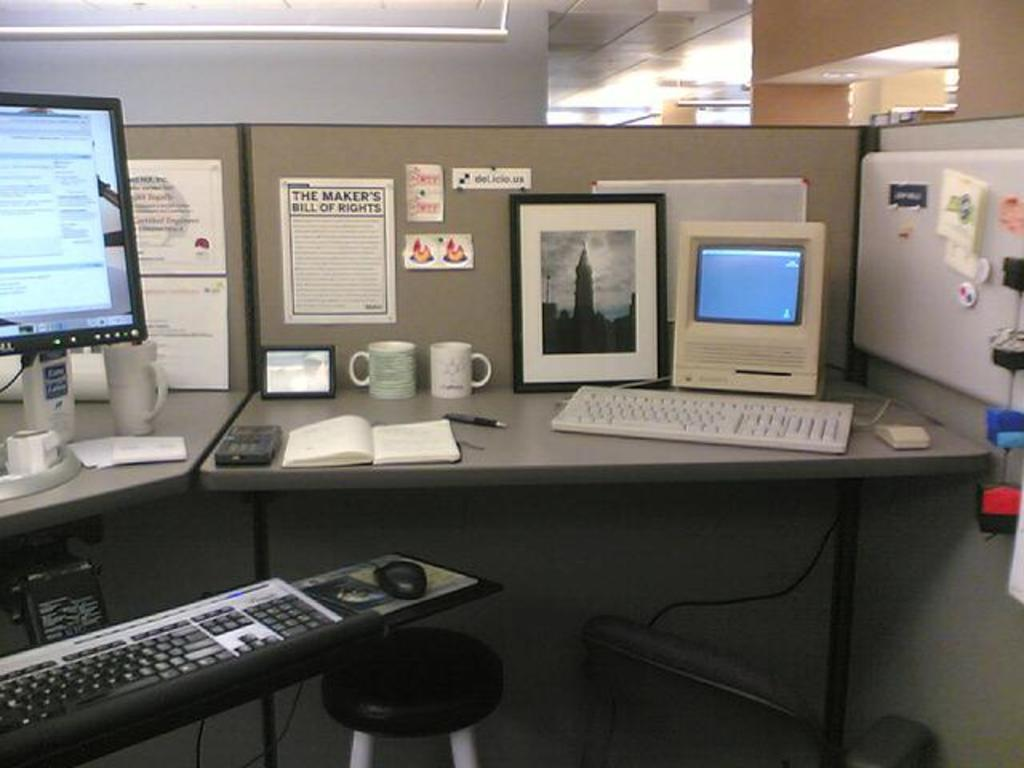<image>
Summarize the visual content of the image. Office space with a paper hanging on the wall which says "The Maker's Bill of Rights". 